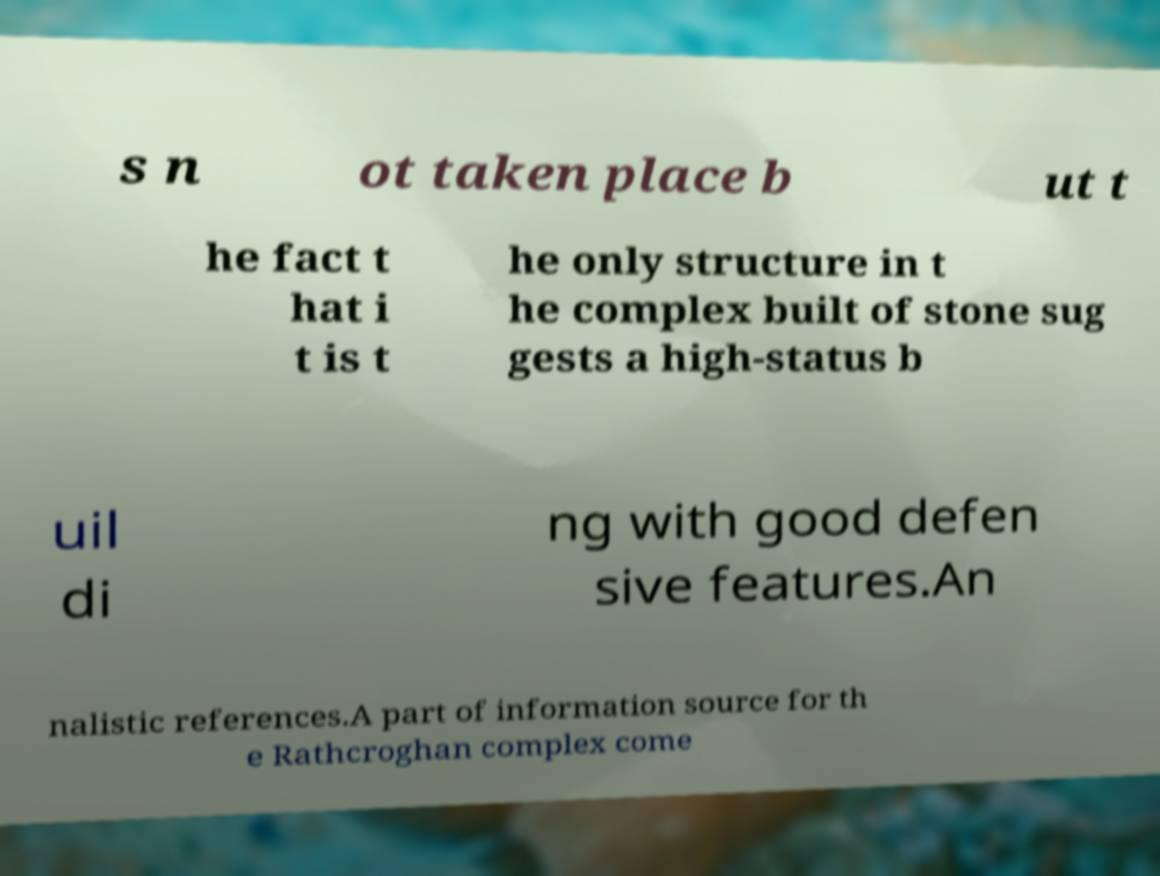Please read and relay the text visible in this image. What does it say? s n ot taken place b ut t he fact t hat i t is t he only structure in t he complex built of stone sug gests a high-status b uil di ng with good defen sive features.An nalistic references.A part of information source for th e Rathcroghan complex come 